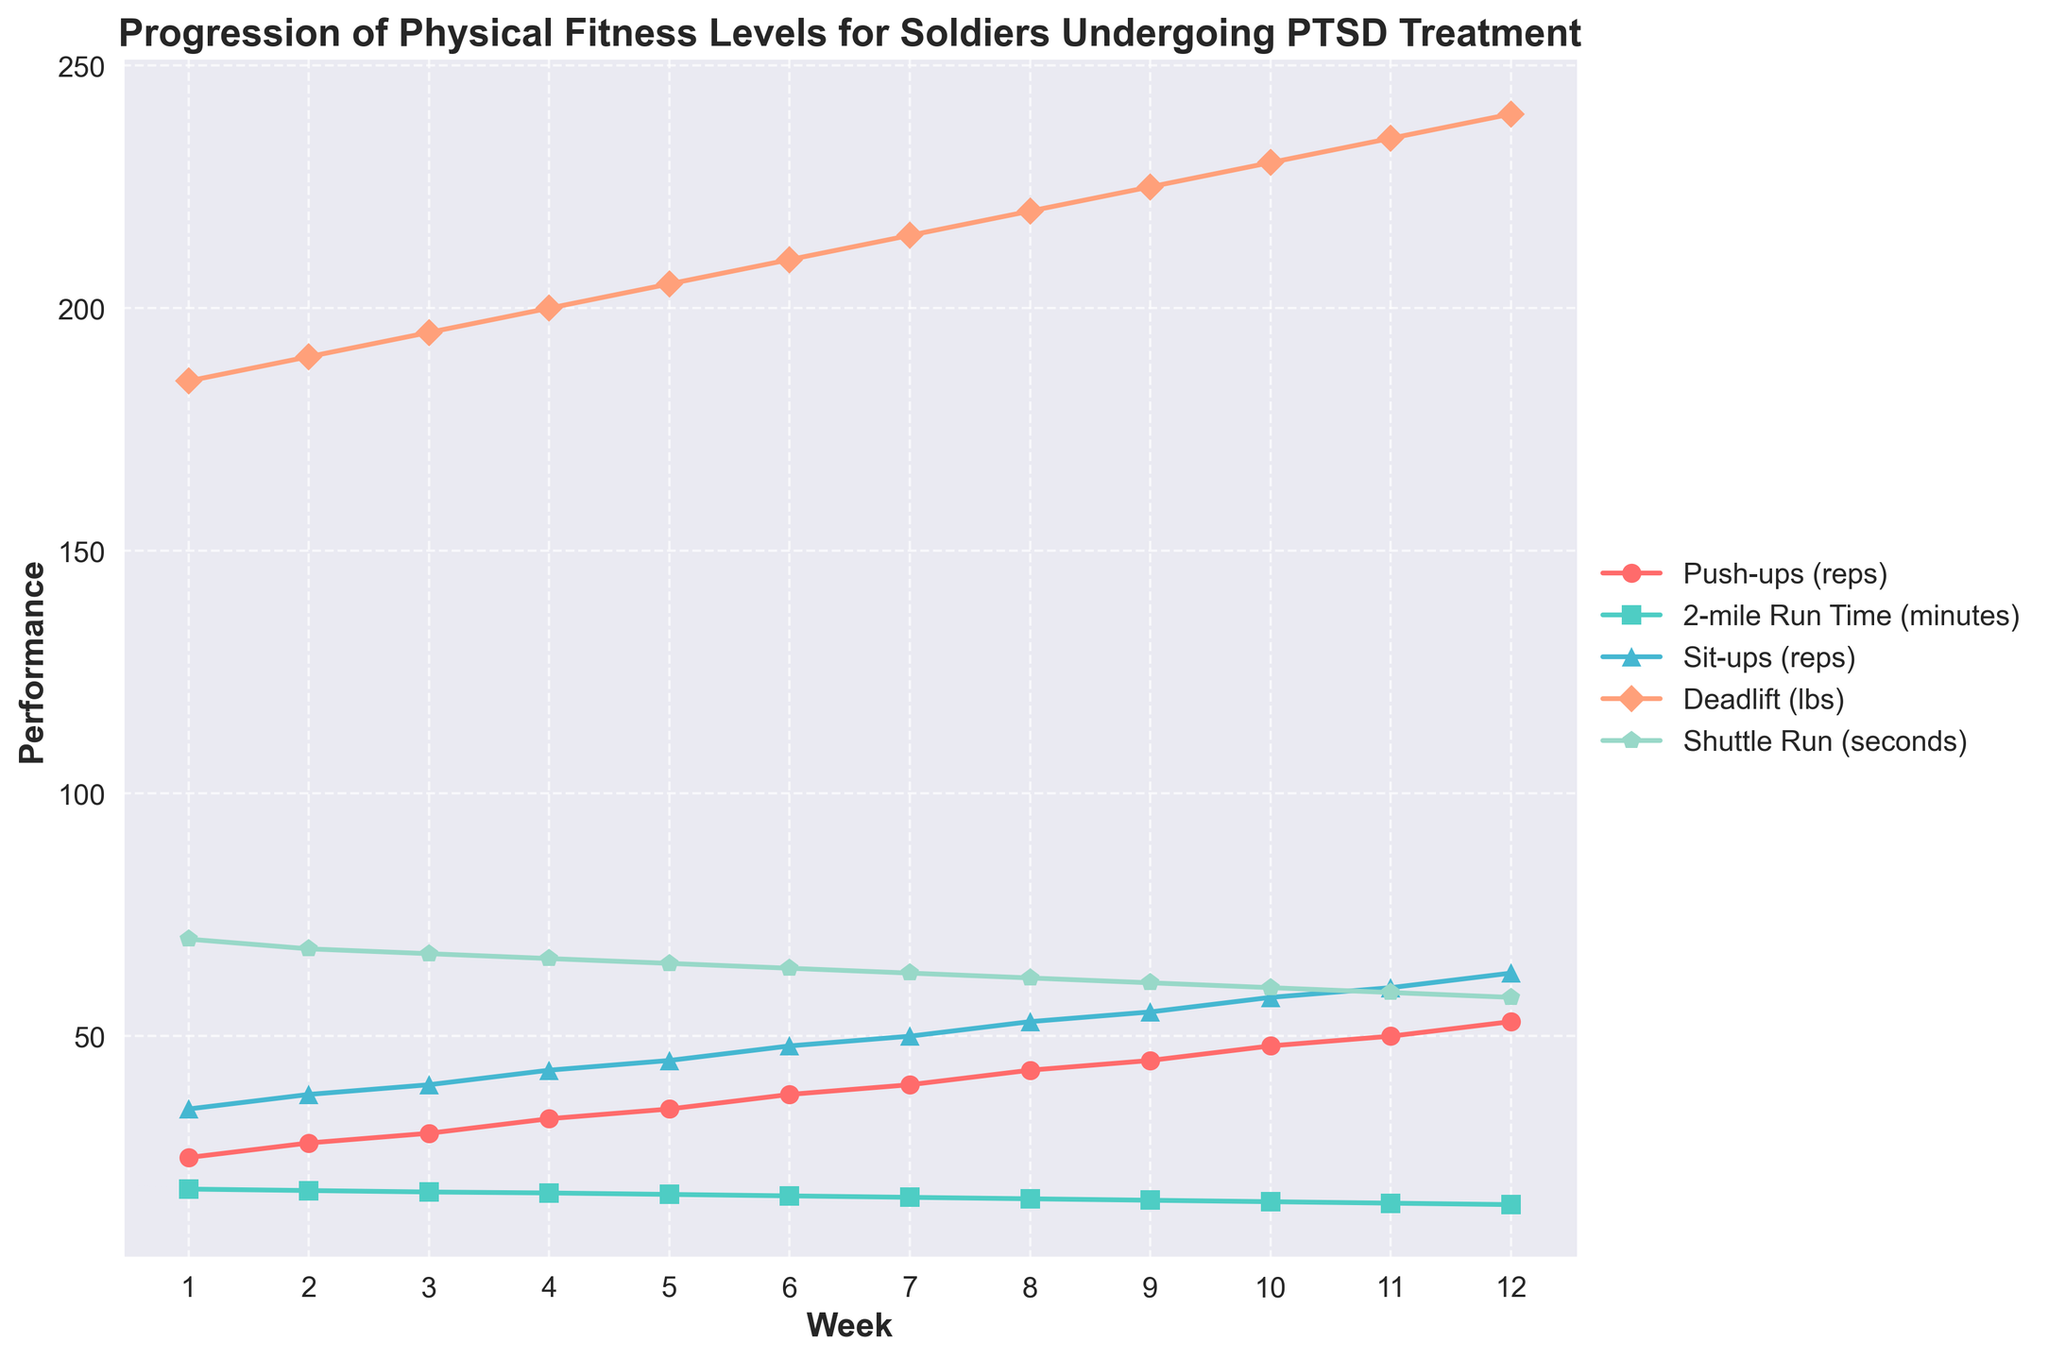What is the improvement in the number of push-ups from Week 1 to Week 12? To find the improvement, subtract the number of push-ups in Week 1 from the number in Week 12 (53 - 25).
Answer: 28 Which metric shows the most significant improvement over the 12 weeks? Examine each metric line in the plot and calculate the difference between the starting and ending points for each metric. The metrics are: Push-ups (53-25 = 28), 2-mile Run Time (18.5-15.3 = 3.2 minutes), Sit-ups (63-35 = 28), Deadlift (240-185 = 55 pounds), Shuttle Run (70-58 = 12 seconds). The largest difference is in the Deadlift.
Answer: Deadlift How does the 2-mile run time (minutes) trend over the 12 weeks? Look at the line representing the 2-mile run time. It starts at 18.5 minutes and decreases steadily over the 12 weeks to 15.3 minutes. This indicates an improving trend.
Answer: Decreasing Which weeks show a push-up count greater than 40 but less than 50? Identify the portion of the push-up line that falls between 40 and 50. This occurs from Week 7 (40) to Week 10 (48).
Answer: Weeks 7 to 10 Compare the trend lines of push-ups and sit-ups. Which one shows a steeper increase? Examine the slopes of the lines for push-ups and sit-ups. Comparing the increment rates, the push-up line (28 reps increase) and sit-up line (28 reps increase) both have equal increments.
Answer: Equal increase During which weeks are the sit-ups reps and deadlift weight exactly equal? Look at the plot to find the intersection points of the sit-ups and deadlift lines. Both lines intersect at Week 3 (40 reps and lbs).
Answer: Week 3 What is the average 2-mile run time between Week 3 and Week 8? To find the average, sum the run times from Week 3 to Week 8 and divide by the number of weeks: (17.9 + 17.7 + 17.4 + 17.1 + 16.8 + 16.5) / 6 = 103.4 / 6.
Answer: 17.23 minutes By how much does the shuttle run time decrease from Week 1 to Week 12? Subtract the shuttle run time in Week 12 from Week 1 (70 - 58).
Answer: 12 seconds Between which weeks does the largest weekly improvement in deadlift weights occur? Calculate the differences in deadlift weights week-to-week: 190-185, 195-190, 200-195, 205-200, 210-205, 215-210, 220-215, 225-220, 230-225, 235-230, 240-235. The largest improvement is consistent at 5 lbs per week.
Answer: All weeks show 5 lbs improvement When do the push-ups and shuttle run times start diverging significantly? Analyze where the lines for push-ups and shuttle runs start showing a distinct difference in their slopes: this starts around Weeks 4-5 when push-up reps increase more sharply while shuttle time decreases steadily.
Answer: Week 4-5 